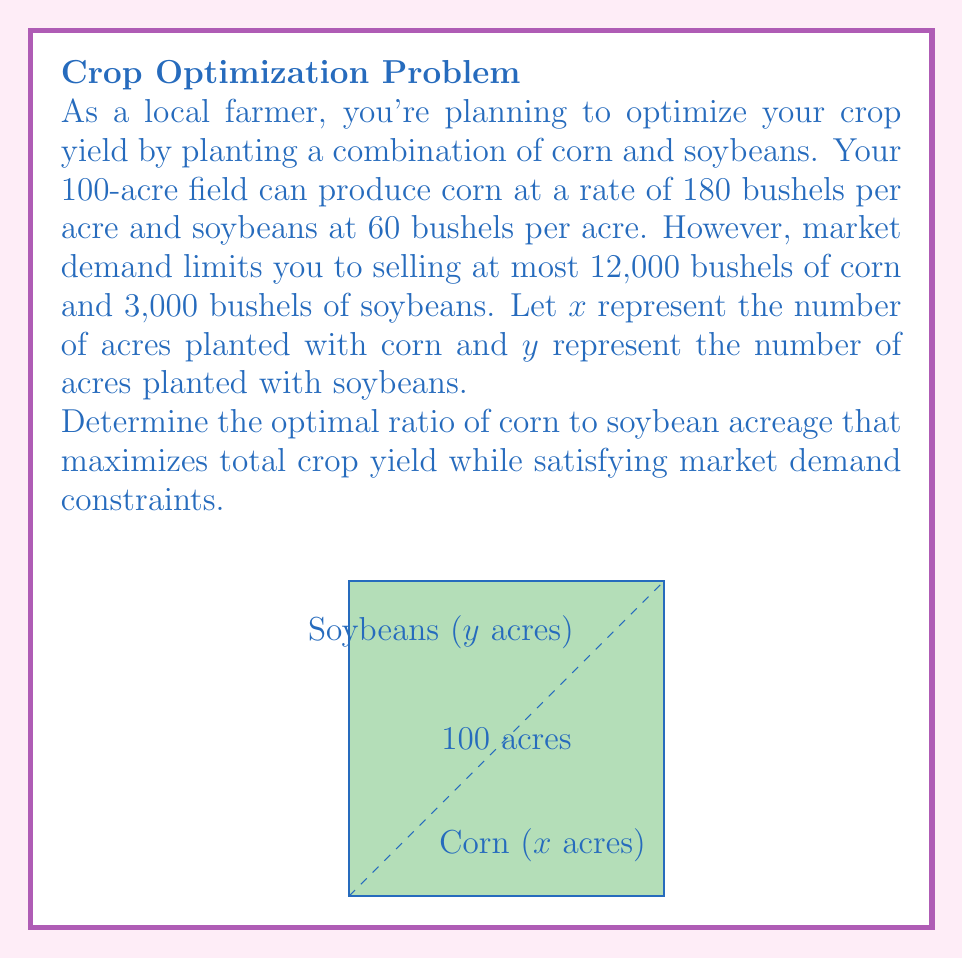Help me with this question. Let's approach this step-by-step:

1) First, we need to set up our constraints based on the given information:

   - Total acreage: $x + y = 100$
   - Corn production: $180x \leq 12000$
   - Soybean production: $60y \leq 3000$

2) Simplify the production constraints:
   
   - Corn: $x \leq \frac{12000}{180} = \frac{200}{3} \approx 66.67$ acres
   - Soybeans: $y \leq \frac{3000}{60} = 50$ acres

3) To maximize total yield, we want to maximize the expression:

   $\text{Total Yield} = 180x + 60y$

4) Given the constraints, we can use all 50 acres for soybeans and the remaining acres for corn:

   $y = 50$
   $x = 100 - 50 = 50$

5) This satisfies all our constraints:
   
   - Total acreage: $50 + 50 = 100$
   - Corn production: $180 \cdot 50 = 9000 \leq 12000$
   - Soybean production: $60 \cdot 50 = 3000 \leq 3000$

6) The ratio of corn to soybean acreage is therefore:

   $\frac{\text{Corn acreage}}{\text{Soybean acreage}} = \frac{50}{50} = 1:1$

This ratio maximizes the total yield while satisfying all constraints.
Answer: 1:1 